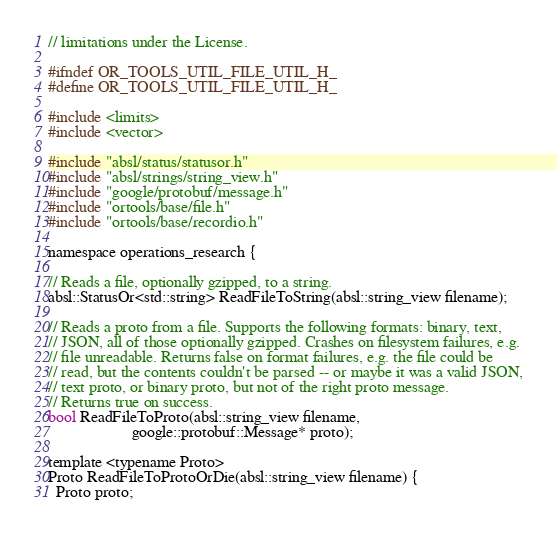Convert code to text. <code><loc_0><loc_0><loc_500><loc_500><_C_>// limitations under the License.

#ifndef OR_TOOLS_UTIL_FILE_UTIL_H_
#define OR_TOOLS_UTIL_FILE_UTIL_H_

#include <limits>
#include <vector>

#include "absl/status/statusor.h"
#include "absl/strings/string_view.h"
#include "google/protobuf/message.h"
#include "ortools/base/file.h"
#include "ortools/base/recordio.h"

namespace operations_research {

// Reads a file, optionally gzipped, to a string.
absl::StatusOr<std::string> ReadFileToString(absl::string_view filename);

// Reads a proto from a file. Supports the following formats: binary, text,
// JSON, all of those optionally gzipped. Crashes on filesystem failures, e.g.
// file unreadable. Returns false on format failures, e.g. the file could be
// read, but the contents couldn't be parsed -- or maybe it was a valid JSON,
// text proto, or binary proto, but not of the right proto message.
// Returns true on success.
bool ReadFileToProto(absl::string_view filename,
                     google::protobuf::Message* proto);

template <typename Proto>
Proto ReadFileToProtoOrDie(absl::string_view filename) {
  Proto proto;</code> 